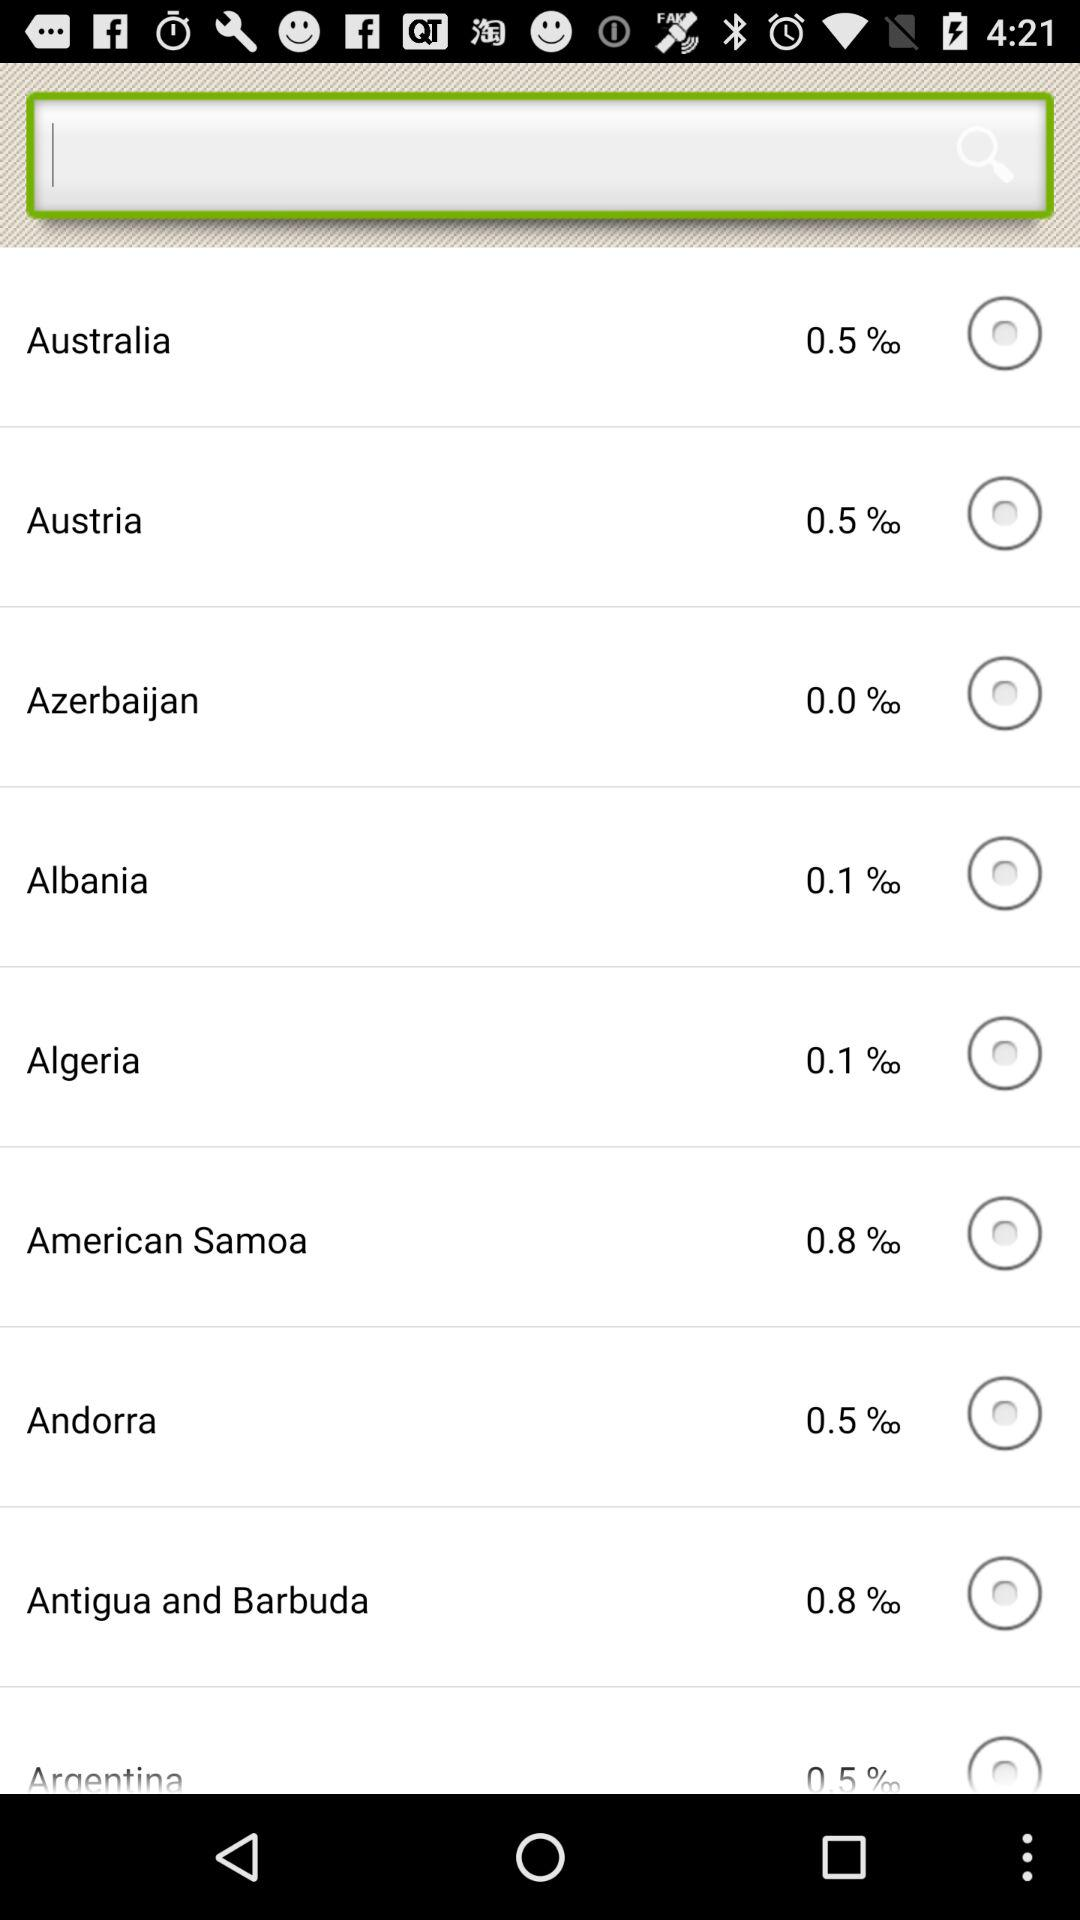What is the percentage of Australia? The percentage of Australia is 0.05. 